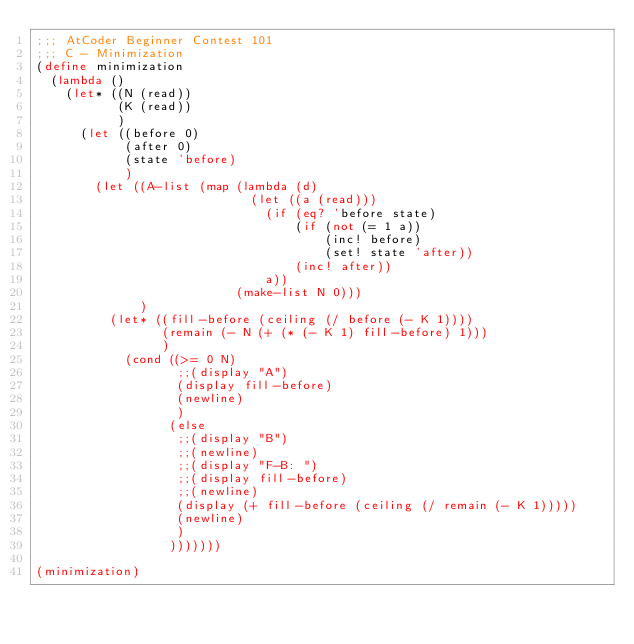<code> <loc_0><loc_0><loc_500><loc_500><_Scheme_>;;; AtCoder Beginner Contest 101
;;; C - Minimization
(define minimization
  (lambda ()
    (let* ((N (read))
           (K (read))
           )
      (let ((before 0)
            (after 0)
            (state 'before)
            )
        (let ((A-list (map (lambda (d)
                             (let ((a (read)))
                               (if (eq? 'before state)
                                   (if (not (= 1 a))
                                       (inc! before)
                                       (set! state 'after))
                                   (inc! after))
                               a))
                           (make-list N 0)))
              )
          (let* ((fill-before (ceiling (/ before (- K 1))))
                 (remain (- N (+ (* (- K 1) fill-before) 1)))
                 )
            (cond ((>= 0 N)
                   ;;(display "A")
                   (display fill-before)
                   (newline)
                   )
                  (else
                   ;;(display "B")
                   ;;(newline)
                   ;;(display "F-B: ")
                   ;;(display fill-before)
                   ;;(newline)
                   (display (+ fill-before (ceiling (/ remain (- K 1)))))
                   (newline)
                   )
                  )))))))

(minimization)
</code> 